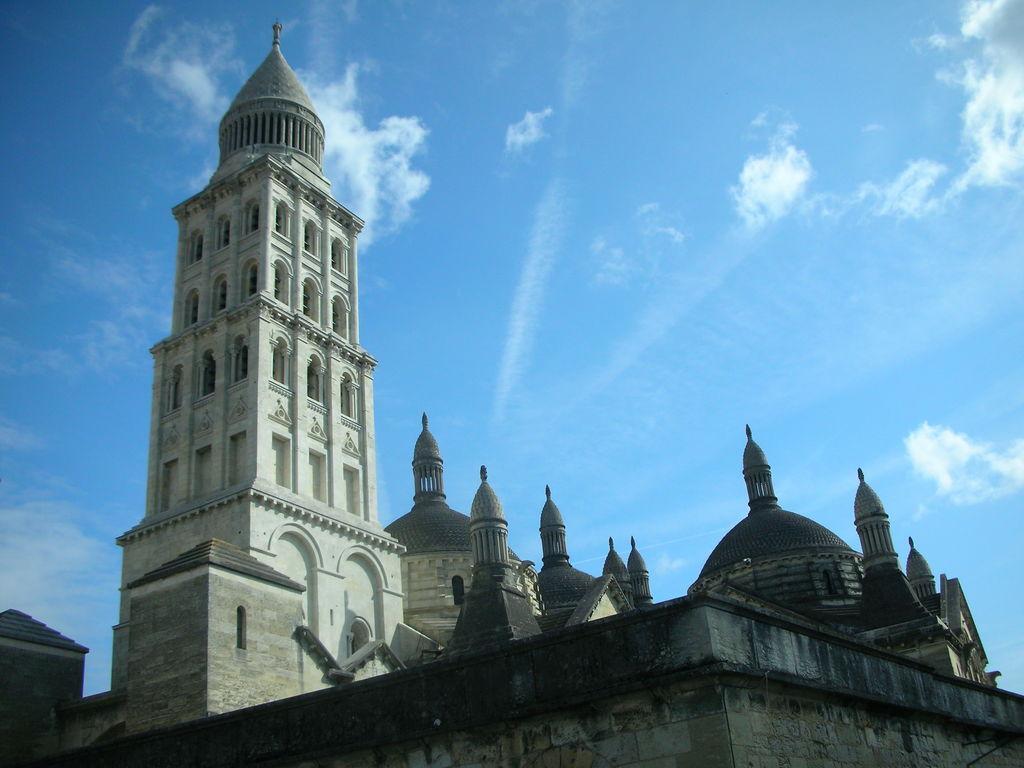Describe this image in one or two sentences. In this image there is a wall in the foreground. There is a tall building. There are clouds in the sky. 